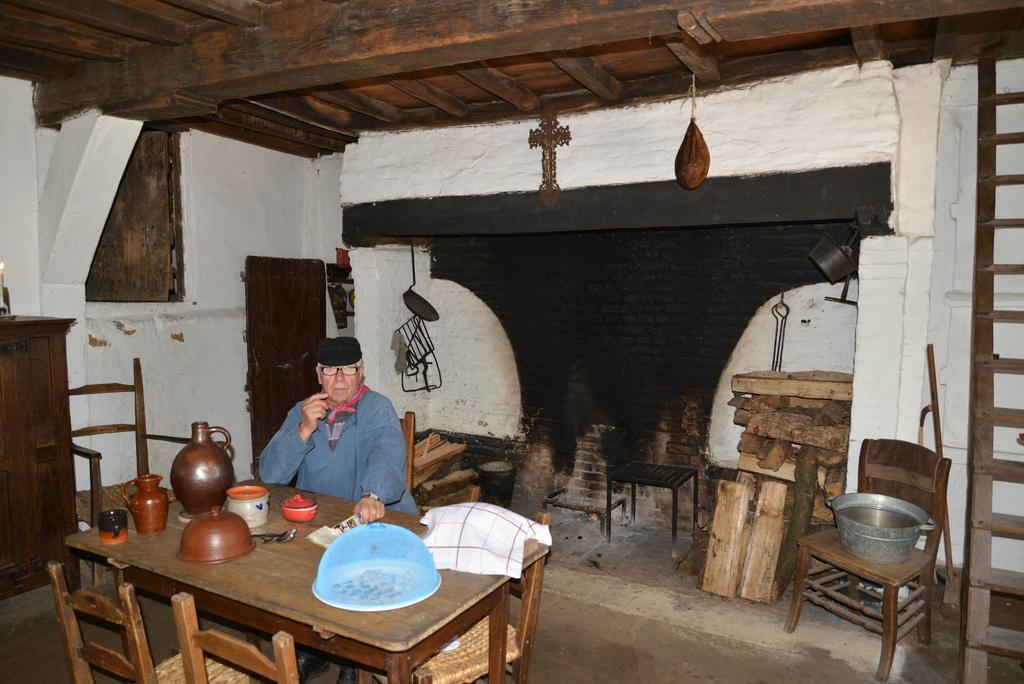What is the person in the image doing? The person is sitting on a chair in the image. What is in front of the person? The person is in front of a table. What can be seen on the table? There are posts, a cup, and a cloth on the table. What can be seen in the background of the image? There is a wall and a roof visible in the background of the image. What language is the person speaking in the image? There is no indication of the person speaking in the image, so it cannot be determined what language they might be using. 